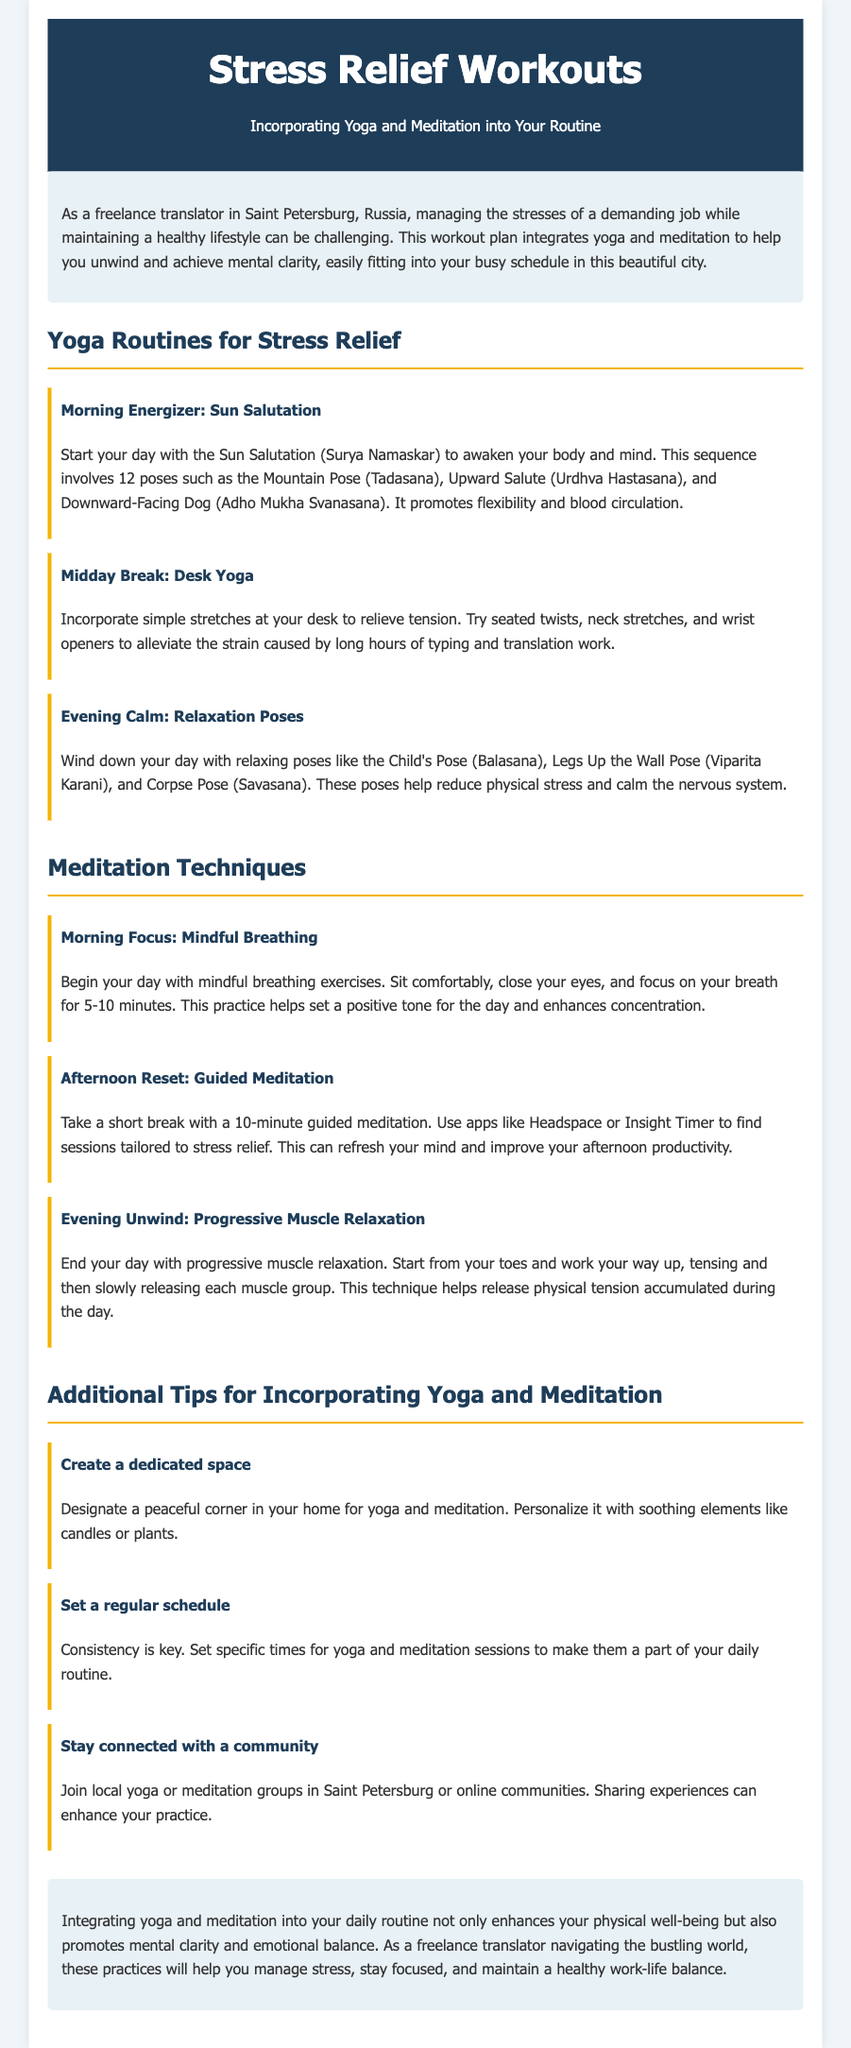what is the title of the workout plan? The title is prominently displayed at the top of the document, which indicates the main focus of the content.
Answer: Stress Relief Workouts who is the intended audience for the workout plan? The introduction identifies the target readers and their context in relation to the content provided.
Answer: freelance translators how many yoga routines are listed in the document? The section on yoga routines counts the various routines presented for stress relief.
Answer: 3 what is the first meditation technique mentioned? The order of the techniques provides the sequence in which they are introduced for practice.
Answer: Mindful Breathing what is a suggested app for guided meditation? The section on meditation techniques mentions specific tools to aid in practice, addressing technology use.
Answer: Headspace which pose is included in the Evening Calm routine? The routines list specific yoga poses meant for relaxation in the evening section.
Answer: Child's Pose what should you create for your yoga and meditation practice? The tips section advises on optimization of practice environments and setups.
Answer: dedicated space how can community involvement benefit yoga practice? The explanation of community suggestions highlights collaborative elements that improve practice quality.
Answer: sharing experiences 